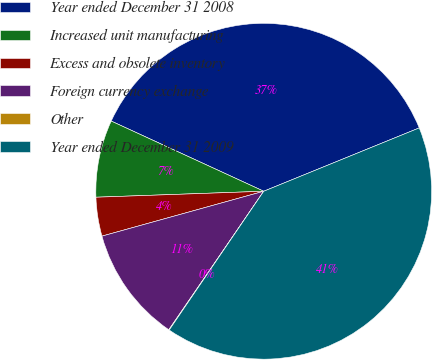Convert chart to OTSL. <chart><loc_0><loc_0><loc_500><loc_500><pie_chart><fcel>Year ended December 31 2008<fcel>Increased unit manufacturing<fcel>Excess and obsolete inventory<fcel>Foreign currency exchange<fcel>Other<fcel>Year ended December 31 2009<nl><fcel>36.98%<fcel>7.43%<fcel>3.74%<fcel>11.13%<fcel>0.05%<fcel>40.67%<nl></chart> 